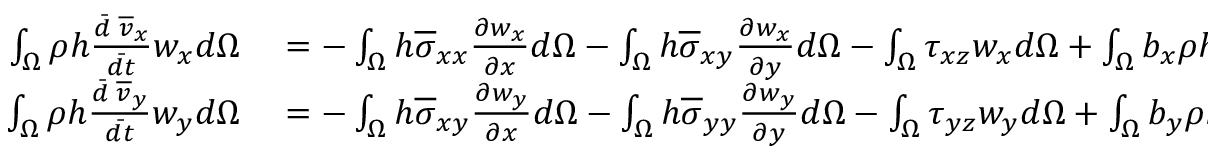<formula> <loc_0><loc_0><loc_500><loc_500>\begin{array} { r l } { \int _ { \Omega } \rho h \frac { \ B a r { d } \, \overline { v } _ { x } } { \ B a r { d t } } w _ { x } d \Omega } & = - \int _ { \Omega } h \overline { \sigma } _ { x x } \frac { \partial w _ { x } } { \partial x } d \Omega - \int _ { \Omega } h \overline { \sigma } _ { x y } \frac { \partial w _ { x } } { \partial y } d \Omega - \int _ { \Omega } \tau _ { x z } w _ { x } d \Omega + \int _ { \Omega } b _ { x } \rho h w _ { x } d \Omega } \\ { \int _ { \Omega } \rho h \frac { \ B a r { d } \, \overline { v } _ { y } } { \ B a r { d t } } w _ { y } d \Omega } & = - \int _ { \Omega } h \overline { \sigma } _ { x y } \frac { \partial w _ { y } } { \partial x } d \Omega - \int _ { \Omega } h \overline { \sigma } _ { y y } \frac { \partial w _ { y } } { \partial y } d \Omega - \int _ { \Omega } \tau _ { y z } w _ { y } d \Omega + \int _ { \Omega } b _ { y } \rho h w _ { y } d \Omega } \end{array}</formula> 